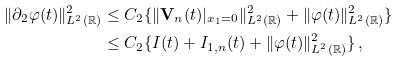<formula> <loc_0><loc_0><loc_500><loc_500>\| \partial _ { 2 } \varphi ( t ) \| ^ { 2 } _ { L ^ { 2 } ( \mathbb { R } ) } & \leq C _ { 2 } \{ \| { \mathbf V } _ { n } ( t ) | _ { x _ { 1 } = 0 } \| ^ { 2 } _ { L ^ { 2 } ( \mathbb { R } ) } + \| \varphi ( t ) \| ^ { 2 } _ { L ^ { 2 } ( \mathbb { R } ) } \} \\ & \leq C _ { 2 } \{ I ( t ) + I _ { 1 , n } ( t ) + \| \varphi ( t ) \| ^ { 2 } _ { L ^ { 2 } ( \mathbb { R } ) } \} \, ,</formula> 